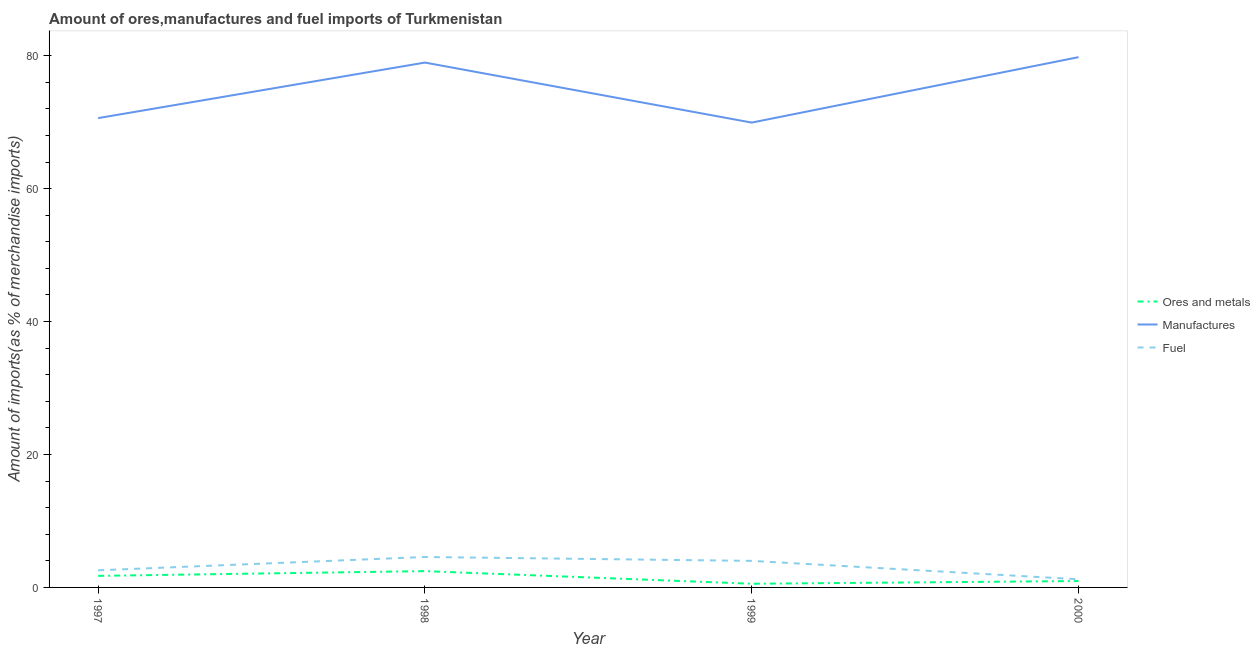How many different coloured lines are there?
Keep it short and to the point. 3. Does the line corresponding to percentage of fuel imports intersect with the line corresponding to percentage of ores and metals imports?
Give a very brief answer. No. Is the number of lines equal to the number of legend labels?
Provide a short and direct response. Yes. What is the percentage of manufactures imports in 1998?
Your answer should be compact. 78.97. Across all years, what is the maximum percentage of manufactures imports?
Keep it short and to the point. 79.78. Across all years, what is the minimum percentage of manufactures imports?
Your response must be concise. 69.94. In which year was the percentage of fuel imports maximum?
Provide a succinct answer. 1998. In which year was the percentage of fuel imports minimum?
Offer a very short reply. 2000. What is the total percentage of ores and metals imports in the graph?
Offer a terse response. 5.71. What is the difference between the percentage of ores and metals imports in 1997 and that in 2000?
Ensure brevity in your answer.  0.78. What is the difference between the percentage of manufactures imports in 2000 and the percentage of ores and metals imports in 1998?
Provide a succinct answer. 77.33. What is the average percentage of ores and metals imports per year?
Your answer should be compact. 1.43. In the year 2000, what is the difference between the percentage of ores and metals imports and percentage of manufactures imports?
Ensure brevity in your answer.  -78.82. What is the ratio of the percentage of ores and metals imports in 1997 to that in 1998?
Offer a terse response. 0.71. Is the difference between the percentage of fuel imports in 1998 and 1999 greater than the difference between the percentage of manufactures imports in 1998 and 1999?
Your answer should be very brief. No. What is the difference between the highest and the second highest percentage of manufactures imports?
Make the answer very short. 0.81. What is the difference between the highest and the lowest percentage of manufactures imports?
Offer a terse response. 9.85. In how many years, is the percentage of ores and metals imports greater than the average percentage of ores and metals imports taken over all years?
Offer a very short reply. 2. Is the sum of the percentage of manufactures imports in 1998 and 1999 greater than the maximum percentage of fuel imports across all years?
Offer a terse response. Yes. Is it the case that in every year, the sum of the percentage of ores and metals imports and percentage of manufactures imports is greater than the percentage of fuel imports?
Your response must be concise. Yes. Does the percentage of ores and metals imports monotonically increase over the years?
Make the answer very short. No. Is the percentage of ores and metals imports strictly less than the percentage of fuel imports over the years?
Offer a very short reply. Yes. How many lines are there?
Provide a short and direct response. 3. How many years are there in the graph?
Provide a succinct answer. 4. Does the graph contain any zero values?
Your response must be concise. No. Where does the legend appear in the graph?
Your answer should be compact. Center right. How many legend labels are there?
Provide a succinct answer. 3. How are the legend labels stacked?
Keep it short and to the point. Vertical. What is the title of the graph?
Ensure brevity in your answer.  Amount of ores,manufactures and fuel imports of Turkmenistan. Does "Manufactures" appear as one of the legend labels in the graph?
Your answer should be compact. Yes. What is the label or title of the Y-axis?
Ensure brevity in your answer.  Amount of imports(as % of merchandise imports). What is the Amount of imports(as % of merchandise imports) in Ores and metals in 1997?
Your answer should be very brief. 1.74. What is the Amount of imports(as % of merchandise imports) of Manufactures in 1997?
Your answer should be compact. 70.61. What is the Amount of imports(as % of merchandise imports) of Fuel in 1997?
Your answer should be compact. 2.57. What is the Amount of imports(as % of merchandise imports) of Ores and metals in 1998?
Keep it short and to the point. 2.45. What is the Amount of imports(as % of merchandise imports) of Manufactures in 1998?
Your answer should be compact. 78.97. What is the Amount of imports(as % of merchandise imports) of Fuel in 1998?
Your answer should be very brief. 4.58. What is the Amount of imports(as % of merchandise imports) of Ores and metals in 1999?
Give a very brief answer. 0.55. What is the Amount of imports(as % of merchandise imports) of Manufactures in 1999?
Provide a succinct answer. 69.94. What is the Amount of imports(as % of merchandise imports) of Fuel in 1999?
Provide a succinct answer. 4. What is the Amount of imports(as % of merchandise imports) of Ores and metals in 2000?
Offer a terse response. 0.96. What is the Amount of imports(as % of merchandise imports) in Manufactures in 2000?
Ensure brevity in your answer.  79.78. What is the Amount of imports(as % of merchandise imports) of Fuel in 2000?
Offer a very short reply. 1.23. Across all years, what is the maximum Amount of imports(as % of merchandise imports) of Ores and metals?
Your answer should be very brief. 2.45. Across all years, what is the maximum Amount of imports(as % of merchandise imports) of Manufactures?
Your answer should be compact. 79.78. Across all years, what is the maximum Amount of imports(as % of merchandise imports) of Fuel?
Provide a short and direct response. 4.58. Across all years, what is the minimum Amount of imports(as % of merchandise imports) in Ores and metals?
Your answer should be very brief. 0.55. Across all years, what is the minimum Amount of imports(as % of merchandise imports) in Manufactures?
Ensure brevity in your answer.  69.94. Across all years, what is the minimum Amount of imports(as % of merchandise imports) in Fuel?
Your response must be concise. 1.23. What is the total Amount of imports(as % of merchandise imports) in Ores and metals in the graph?
Offer a terse response. 5.71. What is the total Amount of imports(as % of merchandise imports) of Manufactures in the graph?
Your answer should be compact. 299.3. What is the total Amount of imports(as % of merchandise imports) in Fuel in the graph?
Offer a terse response. 12.38. What is the difference between the Amount of imports(as % of merchandise imports) of Ores and metals in 1997 and that in 1998?
Your answer should be compact. -0.71. What is the difference between the Amount of imports(as % of merchandise imports) of Manufactures in 1997 and that in 1998?
Offer a terse response. -8.36. What is the difference between the Amount of imports(as % of merchandise imports) in Fuel in 1997 and that in 1998?
Your answer should be compact. -2. What is the difference between the Amount of imports(as % of merchandise imports) in Ores and metals in 1997 and that in 1999?
Your response must be concise. 1.19. What is the difference between the Amount of imports(as % of merchandise imports) of Manufactures in 1997 and that in 1999?
Ensure brevity in your answer.  0.67. What is the difference between the Amount of imports(as % of merchandise imports) in Fuel in 1997 and that in 1999?
Provide a short and direct response. -1.42. What is the difference between the Amount of imports(as % of merchandise imports) of Ores and metals in 1997 and that in 2000?
Ensure brevity in your answer.  0.78. What is the difference between the Amount of imports(as % of merchandise imports) in Manufactures in 1997 and that in 2000?
Offer a terse response. -9.17. What is the difference between the Amount of imports(as % of merchandise imports) of Fuel in 1997 and that in 2000?
Your answer should be very brief. 1.35. What is the difference between the Amount of imports(as % of merchandise imports) in Ores and metals in 1998 and that in 1999?
Provide a succinct answer. 1.9. What is the difference between the Amount of imports(as % of merchandise imports) of Manufactures in 1998 and that in 1999?
Make the answer very short. 9.03. What is the difference between the Amount of imports(as % of merchandise imports) in Fuel in 1998 and that in 1999?
Your answer should be very brief. 0.58. What is the difference between the Amount of imports(as % of merchandise imports) in Ores and metals in 1998 and that in 2000?
Offer a terse response. 1.5. What is the difference between the Amount of imports(as % of merchandise imports) in Manufactures in 1998 and that in 2000?
Offer a very short reply. -0.81. What is the difference between the Amount of imports(as % of merchandise imports) of Fuel in 1998 and that in 2000?
Provide a short and direct response. 3.35. What is the difference between the Amount of imports(as % of merchandise imports) of Ores and metals in 1999 and that in 2000?
Your answer should be very brief. -0.41. What is the difference between the Amount of imports(as % of merchandise imports) in Manufactures in 1999 and that in 2000?
Offer a terse response. -9.85. What is the difference between the Amount of imports(as % of merchandise imports) in Fuel in 1999 and that in 2000?
Your answer should be compact. 2.77. What is the difference between the Amount of imports(as % of merchandise imports) in Ores and metals in 1997 and the Amount of imports(as % of merchandise imports) in Manufactures in 1998?
Provide a short and direct response. -77.23. What is the difference between the Amount of imports(as % of merchandise imports) in Ores and metals in 1997 and the Amount of imports(as % of merchandise imports) in Fuel in 1998?
Your answer should be compact. -2.84. What is the difference between the Amount of imports(as % of merchandise imports) of Manufactures in 1997 and the Amount of imports(as % of merchandise imports) of Fuel in 1998?
Ensure brevity in your answer.  66.03. What is the difference between the Amount of imports(as % of merchandise imports) of Ores and metals in 1997 and the Amount of imports(as % of merchandise imports) of Manufactures in 1999?
Ensure brevity in your answer.  -68.2. What is the difference between the Amount of imports(as % of merchandise imports) in Ores and metals in 1997 and the Amount of imports(as % of merchandise imports) in Fuel in 1999?
Give a very brief answer. -2.26. What is the difference between the Amount of imports(as % of merchandise imports) in Manufactures in 1997 and the Amount of imports(as % of merchandise imports) in Fuel in 1999?
Keep it short and to the point. 66.62. What is the difference between the Amount of imports(as % of merchandise imports) of Ores and metals in 1997 and the Amount of imports(as % of merchandise imports) of Manufactures in 2000?
Make the answer very short. -78.04. What is the difference between the Amount of imports(as % of merchandise imports) of Ores and metals in 1997 and the Amount of imports(as % of merchandise imports) of Fuel in 2000?
Give a very brief answer. 0.51. What is the difference between the Amount of imports(as % of merchandise imports) in Manufactures in 1997 and the Amount of imports(as % of merchandise imports) in Fuel in 2000?
Give a very brief answer. 69.39. What is the difference between the Amount of imports(as % of merchandise imports) of Ores and metals in 1998 and the Amount of imports(as % of merchandise imports) of Manufactures in 1999?
Your answer should be very brief. -67.48. What is the difference between the Amount of imports(as % of merchandise imports) in Ores and metals in 1998 and the Amount of imports(as % of merchandise imports) in Fuel in 1999?
Keep it short and to the point. -1.54. What is the difference between the Amount of imports(as % of merchandise imports) in Manufactures in 1998 and the Amount of imports(as % of merchandise imports) in Fuel in 1999?
Give a very brief answer. 74.97. What is the difference between the Amount of imports(as % of merchandise imports) in Ores and metals in 1998 and the Amount of imports(as % of merchandise imports) in Manufactures in 2000?
Keep it short and to the point. -77.33. What is the difference between the Amount of imports(as % of merchandise imports) in Ores and metals in 1998 and the Amount of imports(as % of merchandise imports) in Fuel in 2000?
Give a very brief answer. 1.23. What is the difference between the Amount of imports(as % of merchandise imports) of Manufactures in 1998 and the Amount of imports(as % of merchandise imports) of Fuel in 2000?
Ensure brevity in your answer.  77.74. What is the difference between the Amount of imports(as % of merchandise imports) of Ores and metals in 1999 and the Amount of imports(as % of merchandise imports) of Manufactures in 2000?
Your answer should be compact. -79.23. What is the difference between the Amount of imports(as % of merchandise imports) in Ores and metals in 1999 and the Amount of imports(as % of merchandise imports) in Fuel in 2000?
Offer a terse response. -0.67. What is the difference between the Amount of imports(as % of merchandise imports) in Manufactures in 1999 and the Amount of imports(as % of merchandise imports) in Fuel in 2000?
Your response must be concise. 68.71. What is the average Amount of imports(as % of merchandise imports) in Ores and metals per year?
Offer a very short reply. 1.43. What is the average Amount of imports(as % of merchandise imports) in Manufactures per year?
Offer a very short reply. 74.83. What is the average Amount of imports(as % of merchandise imports) of Fuel per year?
Give a very brief answer. 3.09. In the year 1997, what is the difference between the Amount of imports(as % of merchandise imports) of Ores and metals and Amount of imports(as % of merchandise imports) of Manufactures?
Provide a succinct answer. -68.87. In the year 1997, what is the difference between the Amount of imports(as % of merchandise imports) in Ores and metals and Amount of imports(as % of merchandise imports) in Fuel?
Provide a succinct answer. -0.84. In the year 1997, what is the difference between the Amount of imports(as % of merchandise imports) in Manufactures and Amount of imports(as % of merchandise imports) in Fuel?
Make the answer very short. 68.04. In the year 1998, what is the difference between the Amount of imports(as % of merchandise imports) in Ores and metals and Amount of imports(as % of merchandise imports) in Manufactures?
Provide a short and direct response. -76.52. In the year 1998, what is the difference between the Amount of imports(as % of merchandise imports) of Ores and metals and Amount of imports(as % of merchandise imports) of Fuel?
Keep it short and to the point. -2.12. In the year 1998, what is the difference between the Amount of imports(as % of merchandise imports) in Manufactures and Amount of imports(as % of merchandise imports) in Fuel?
Your answer should be very brief. 74.39. In the year 1999, what is the difference between the Amount of imports(as % of merchandise imports) of Ores and metals and Amount of imports(as % of merchandise imports) of Manufactures?
Your answer should be compact. -69.38. In the year 1999, what is the difference between the Amount of imports(as % of merchandise imports) of Ores and metals and Amount of imports(as % of merchandise imports) of Fuel?
Offer a very short reply. -3.44. In the year 1999, what is the difference between the Amount of imports(as % of merchandise imports) of Manufactures and Amount of imports(as % of merchandise imports) of Fuel?
Give a very brief answer. 65.94. In the year 2000, what is the difference between the Amount of imports(as % of merchandise imports) of Ores and metals and Amount of imports(as % of merchandise imports) of Manufactures?
Provide a short and direct response. -78.82. In the year 2000, what is the difference between the Amount of imports(as % of merchandise imports) of Ores and metals and Amount of imports(as % of merchandise imports) of Fuel?
Ensure brevity in your answer.  -0.27. In the year 2000, what is the difference between the Amount of imports(as % of merchandise imports) of Manufactures and Amount of imports(as % of merchandise imports) of Fuel?
Keep it short and to the point. 78.56. What is the ratio of the Amount of imports(as % of merchandise imports) of Ores and metals in 1997 to that in 1998?
Your response must be concise. 0.71. What is the ratio of the Amount of imports(as % of merchandise imports) of Manufactures in 1997 to that in 1998?
Provide a short and direct response. 0.89. What is the ratio of the Amount of imports(as % of merchandise imports) of Fuel in 1997 to that in 1998?
Provide a succinct answer. 0.56. What is the ratio of the Amount of imports(as % of merchandise imports) of Ores and metals in 1997 to that in 1999?
Ensure brevity in your answer.  3.15. What is the ratio of the Amount of imports(as % of merchandise imports) of Manufactures in 1997 to that in 1999?
Your response must be concise. 1.01. What is the ratio of the Amount of imports(as % of merchandise imports) of Fuel in 1997 to that in 1999?
Provide a short and direct response. 0.64. What is the ratio of the Amount of imports(as % of merchandise imports) of Ores and metals in 1997 to that in 2000?
Ensure brevity in your answer.  1.81. What is the ratio of the Amount of imports(as % of merchandise imports) in Manufactures in 1997 to that in 2000?
Give a very brief answer. 0.89. What is the ratio of the Amount of imports(as % of merchandise imports) of Fuel in 1997 to that in 2000?
Give a very brief answer. 2.1. What is the ratio of the Amount of imports(as % of merchandise imports) in Ores and metals in 1998 to that in 1999?
Provide a short and direct response. 4.44. What is the ratio of the Amount of imports(as % of merchandise imports) of Manufactures in 1998 to that in 1999?
Keep it short and to the point. 1.13. What is the ratio of the Amount of imports(as % of merchandise imports) in Fuel in 1998 to that in 1999?
Your answer should be compact. 1.15. What is the ratio of the Amount of imports(as % of merchandise imports) in Ores and metals in 1998 to that in 2000?
Give a very brief answer. 2.56. What is the ratio of the Amount of imports(as % of merchandise imports) in Manufactures in 1998 to that in 2000?
Your answer should be very brief. 0.99. What is the ratio of the Amount of imports(as % of merchandise imports) of Fuel in 1998 to that in 2000?
Make the answer very short. 3.73. What is the ratio of the Amount of imports(as % of merchandise imports) of Ores and metals in 1999 to that in 2000?
Offer a very short reply. 0.58. What is the ratio of the Amount of imports(as % of merchandise imports) in Manufactures in 1999 to that in 2000?
Keep it short and to the point. 0.88. What is the ratio of the Amount of imports(as % of merchandise imports) in Fuel in 1999 to that in 2000?
Keep it short and to the point. 3.26. What is the difference between the highest and the second highest Amount of imports(as % of merchandise imports) in Ores and metals?
Your answer should be compact. 0.71. What is the difference between the highest and the second highest Amount of imports(as % of merchandise imports) of Manufactures?
Your response must be concise. 0.81. What is the difference between the highest and the second highest Amount of imports(as % of merchandise imports) in Fuel?
Your answer should be compact. 0.58. What is the difference between the highest and the lowest Amount of imports(as % of merchandise imports) of Ores and metals?
Offer a very short reply. 1.9. What is the difference between the highest and the lowest Amount of imports(as % of merchandise imports) of Manufactures?
Ensure brevity in your answer.  9.85. What is the difference between the highest and the lowest Amount of imports(as % of merchandise imports) of Fuel?
Make the answer very short. 3.35. 